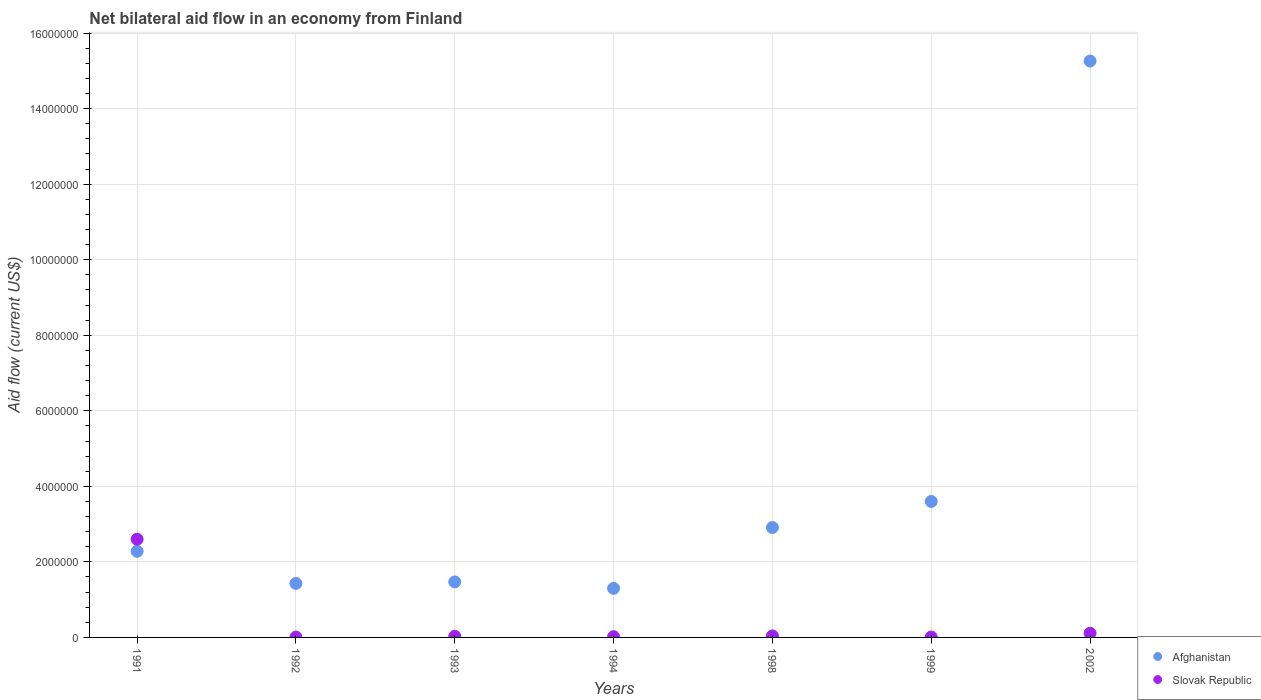What is the net bilateral aid flow in Slovak Republic in 1991?
Ensure brevity in your answer.  2.60e+06. Across all years, what is the maximum net bilateral aid flow in Afghanistan?
Your answer should be compact. 1.53e+07. Across all years, what is the minimum net bilateral aid flow in Afghanistan?
Your response must be concise. 1.30e+06. What is the total net bilateral aid flow in Slovak Republic in the graph?
Offer a terse response. 2.82e+06. What is the difference between the net bilateral aid flow in Slovak Republic in 1992 and that in 1994?
Your response must be concise. -10000. What is the difference between the net bilateral aid flow in Slovak Republic in 1993 and the net bilateral aid flow in Afghanistan in 2002?
Provide a short and direct response. -1.52e+07. What is the average net bilateral aid flow in Slovak Republic per year?
Ensure brevity in your answer.  4.03e+05. In the year 1999, what is the difference between the net bilateral aid flow in Afghanistan and net bilateral aid flow in Slovak Republic?
Keep it short and to the point. 3.59e+06. What is the ratio of the net bilateral aid flow in Slovak Republic in 1992 to that in 2002?
Your response must be concise. 0.09. Is the net bilateral aid flow in Afghanistan in 1998 less than that in 2002?
Keep it short and to the point. Yes. Is the difference between the net bilateral aid flow in Afghanistan in 1994 and 2002 greater than the difference between the net bilateral aid flow in Slovak Republic in 1994 and 2002?
Offer a terse response. No. What is the difference between the highest and the second highest net bilateral aid flow in Slovak Republic?
Provide a short and direct response. 2.49e+06. What is the difference between the highest and the lowest net bilateral aid flow in Afghanistan?
Ensure brevity in your answer.  1.40e+07. Is the sum of the net bilateral aid flow in Slovak Republic in 1994 and 1999 greater than the maximum net bilateral aid flow in Afghanistan across all years?
Your answer should be very brief. No. Does the net bilateral aid flow in Afghanistan monotonically increase over the years?
Make the answer very short. No. How many years are there in the graph?
Your answer should be compact. 7. Does the graph contain grids?
Your response must be concise. Yes. What is the title of the graph?
Provide a short and direct response. Net bilateral aid flow in an economy from Finland. What is the Aid flow (current US$) in Afghanistan in 1991?
Offer a very short reply. 2.28e+06. What is the Aid flow (current US$) of Slovak Republic in 1991?
Ensure brevity in your answer.  2.60e+06. What is the Aid flow (current US$) of Afghanistan in 1992?
Give a very brief answer. 1.43e+06. What is the Aid flow (current US$) of Afghanistan in 1993?
Ensure brevity in your answer.  1.47e+06. What is the Aid flow (current US$) in Slovak Republic in 1993?
Make the answer very short. 3.00e+04. What is the Aid flow (current US$) of Afghanistan in 1994?
Offer a terse response. 1.30e+06. What is the Aid flow (current US$) in Slovak Republic in 1994?
Make the answer very short. 2.00e+04. What is the Aid flow (current US$) of Afghanistan in 1998?
Ensure brevity in your answer.  2.91e+06. What is the Aid flow (current US$) of Afghanistan in 1999?
Make the answer very short. 3.60e+06. What is the Aid flow (current US$) of Afghanistan in 2002?
Offer a very short reply. 1.53e+07. Across all years, what is the maximum Aid flow (current US$) of Afghanistan?
Your answer should be very brief. 1.53e+07. Across all years, what is the maximum Aid flow (current US$) of Slovak Republic?
Keep it short and to the point. 2.60e+06. Across all years, what is the minimum Aid flow (current US$) in Afghanistan?
Offer a terse response. 1.30e+06. Across all years, what is the minimum Aid flow (current US$) in Slovak Republic?
Your answer should be very brief. 10000. What is the total Aid flow (current US$) of Afghanistan in the graph?
Offer a terse response. 2.82e+07. What is the total Aid flow (current US$) of Slovak Republic in the graph?
Ensure brevity in your answer.  2.82e+06. What is the difference between the Aid flow (current US$) in Afghanistan in 1991 and that in 1992?
Offer a terse response. 8.50e+05. What is the difference between the Aid flow (current US$) of Slovak Republic in 1991 and that in 1992?
Your response must be concise. 2.59e+06. What is the difference between the Aid flow (current US$) in Afghanistan in 1991 and that in 1993?
Keep it short and to the point. 8.10e+05. What is the difference between the Aid flow (current US$) in Slovak Republic in 1991 and that in 1993?
Provide a short and direct response. 2.57e+06. What is the difference between the Aid flow (current US$) of Afghanistan in 1991 and that in 1994?
Ensure brevity in your answer.  9.80e+05. What is the difference between the Aid flow (current US$) in Slovak Republic in 1991 and that in 1994?
Ensure brevity in your answer.  2.58e+06. What is the difference between the Aid flow (current US$) of Afghanistan in 1991 and that in 1998?
Your response must be concise. -6.30e+05. What is the difference between the Aid flow (current US$) of Slovak Republic in 1991 and that in 1998?
Offer a terse response. 2.56e+06. What is the difference between the Aid flow (current US$) of Afghanistan in 1991 and that in 1999?
Your answer should be very brief. -1.32e+06. What is the difference between the Aid flow (current US$) in Slovak Republic in 1991 and that in 1999?
Make the answer very short. 2.59e+06. What is the difference between the Aid flow (current US$) of Afghanistan in 1991 and that in 2002?
Your response must be concise. -1.30e+07. What is the difference between the Aid flow (current US$) in Slovak Republic in 1991 and that in 2002?
Keep it short and to the point. 2.49e+06. What is the difference between the Aid flow (current US$) in Afghanistan in 1992 and that in 1993?
Provide a succinct answer. -4.00e+04. What is the difference between the Aid flow (current US$) of Slovak Republic in 1992 and that in 1993?
Give a very brief answer. -2.00e+04. What is the difference between the Aid flow (current US$) of Afghanistan in 1992 and that in 1994?
Offer a terse response. 1.30e+05. What is the difference between the Aid flow (current US$) in Slovak Republic in 1992 and that in 1994?
Your answer should be very brief. -10000. What is the difference between the Aid flow (current US$) of Afghanistan in 1992 and that in 1998?
Keep it short and to the point. -1.48e+06. What is the difference between the Aid flow (current US$) of Slovak Republic in 1992 and that in 1998?
Your answer should be compact. -3.00e+04. What is the difference between the Aid flow (current US$) in Afghanistan in 1992 and that in 1999?
Keep it short and to the point. -2.17e+06. What is the difference between the Aid flow (current US$) of Afghanistan in 1992 and that in 2002?
Make the answer very short. -1.38e+07. What is the difference between the Aid flow (current US$) in Afghanistan in 1993 and that in 1994?
Offer a terse response. 1.70e+05. What is the difference between the Aid flow (current US$) in Afghanistan in 1993 and that in 1998?
Provide a short and direct response. -1.44e+06. What is the difference between the Aid flow (current US$) of Afghanistan in 1993 and that in 1999?
Make the answer very short. -2.13e+06. What is the difference between the Aid flow (current US$) in Afghanistan in 1993 and that in 2002?
Your response must be concise. -1.38e+07. What is the difference between the Aid flow (current US$) of Slovak Republic in 1993 and that in 2002?
Your answer should be very brief. -8.00e+04. What is the difference between the Aid flow (current US$) of Afghanistan in 1994 and that in 1998?
Ensure brevity in your answer.  -1.61e+06. What is the difference between the Aid flow (current US$) in Slovak Republic in 1994 and that in 1998?
Ensure brevity in your answer.  -2.00e+04. What is the difference between the Aid flow (current US$) of Afghanistan in 1994 and that in 1999?
Your answer should be compact. -2.30e+06. What is the difference between the Aid flow (current US$) of Slovak Republic in 1994 and that in 1999?
Provide a succinct answer. 10000. What is the difference between the Aid flow (current US$) of Afghanistan in 1994 and that in 2002?
Provide a short and direct response. -1.40e+07. What is the difference between the Aid flow (current US$) of Slovak Republic in 1994 and that in 2002?
Provide a succinct answer. -9.00e+04. What is the difference between the Aid flow (current US$) of Afghanistan in 1998 and that in 1999?
Ensure brevity in your answer.  -6.90e+05. What is the difference between the Aid flow (current US$) of Slovak Republic in 1998 and that in 1999?
Make the answer very short. 3.00e+04. What is the difference between the Aid flow (current US$) of Afghanistan in 1998 and that in 2002?
Your answer should be compact. -1.24e+07. What is the difference between the Aid flow (current US$) in Slovak Republic in 1998 and that in 2002?
Provide a short and direct response. -7.00e+04. What is the difference between the Aid flow (current US$) in Afghanistan in 1999 and that in 2002?
Your answer should be compact. -1.17e+07. What is the difference between the Aid flow (current US$) of Slovak Republic in 1999 and that in 2002?
Ensure brevity in your answer.  -1.00e+05. What is the difference between the Aid flow (current US$) in Afghanistan in 1991 and the Aid flow (current US$) in Slovak Republic in 1992?
Ensure brevity in your answer.  2.27e+06. What is the difference between the Aid flow (current US$) in Afghanistan in 1991 and the Aid flow (current US$) in Slovak Republic in 1993?
Give a very brief answer. 2.25e+06. What is the difference between the Aid flow (current US$) of Afghanistan in 1991 and the Aid flow (current US$) of Slovak Republic in 1994?
Your answer should be compact. 2.26e+06. What is the difference between the Aid flow (current US$) in Afghanistan in 1991 and the Aid flow (current US$) in Slovak Republic in 1998?
Keep it short and to the point. 2.24e+06. What is the difference between the Aid flow (current US$) of Afghanistan in 1991 and the Aid flow (current US$) of Slovak Republic in 1999?
Your answer should be very brief. 2.27e+06. What is the difference between the Aid flow (current US$) in Afghanistan in 1991 and the Aid flow (current US$) in Slovak Republic in 2002?
Offer a very short reply. 2.17e+06. What is the difference between the Aid flow (current US$) of Afghanistan in 1992 and the Aid flow (current US$) of Slovak Republic in 1993?
Offer a very short reply. 1.40e+06. What is the difference between the Aid flow (current US$) in Afghanistan in 1992 and the Aid flow (current US$) in Slovak Republic in 1994?
Your response must be concise. 1.41e+06. What is the difference between the Aid flow (current US$) of Afghanistan in 1992 and the Aid flow (current US$) of Slovak Republic in 1998?
Give a very brief answer. 1.39e+06. What is the difference between the Aid flow (current US$) of Afghanistan in 1992 and the Aid flow (current US$) of Slovak Republic in 1999?
Keep it short and to the point. 1.42e+06. What is the difference between the Aid flow (current US$) of Afghanistan in 1992 and the Aid flow (current US$) of Slovak Republic in 2002?
Keep it short and to the point. 1.32e+06. What is the difference between the Aid flow (current US$) in Afghanistan in 1993 and the Aid flow (current US$) in Slovak Republic in 1994?
Keep it short and to the point. 1.45e+06. What is the difference between the Aid flow (current US$) in Afghanistan in 1993 and the Aid flow (current US$) in Slovak Republic in 1998?
Your answer should be very brief. 1.43e+06. What is the difference between the Aid flow (current US$) in Afghanistan in 1993 and the Aid flow (current US$) in Slovak Republic in 1999?
Ensure brevity in your answer.  1.46e+06. What is the difference between the Aid flow (current US$) in Afghanistan in 1993 and the Aid flow (current US$) in Slovak Republic in 2002?
Ensure brevity in your answer.  1.36e+06. What is the difference between the Aid flow (current US$) of Afghanistan in 1994 and the Aid flow (current US$) of Slovak Republic in 1998?
Offer a very short reply. 1.26e+06. What is the difference between the Aid flow (current US$) in Afghanistan in 1994 and the Aid flow (current US$) in Slovak Republic in 1999?
Your answer should be very brief. 1.29e+06. What is the difference between the Aid flow (current US$) of Afghanistan in 1994 and the Aid flow (current US$) of Slovak Republic in 2002?
Provide a short and direct response. 1.19e+06. What is the difference between the Aid flow (current US$) in Afghanistan in 1998 and the Aid flow (current US$) in Slovak Republic in 1999?
Make the answer very short. 2.90e+06. What is the difference between the Aid flow (current US$) of Afghanistan in 1998 and the Aid flow (current US$) of Slovak Republic in 2002?
Your answer should be very brief. 2.80e+06. What is the difference between the Aid flow (current US$) in Afghanistan in 1999 and the Aid flow (current US$) in Slovak Republic in 2002?
Provide a succinct answer. 3.49e+06. What is the average Aid flow (current US$) in Afghanistan per year?
Offer a very short reply. 4.04e+06. What is the average Aid flow (current US$) of Slovak Republic per year?
Provide a short and direct response. 4.03e+05. In the year 1991, what is the difference between the Aid flow (current US$) in Afghanistan and Aid flow (current US$) in Slovak Republic?
Ensure brevity in your answer.  -3.20e+05. In the year 1992, what is the difference between the Aid flow (current US$) in Afghanistan and Aid flow (current US$) in Slovak Republic?
Keep it short and to the point. 1.42e+06. In the year 1993, what is the difference between the Aid flow (current US$) in Afghanistan and Aid flow (current US$) in Slovak Republic?
Provide a succinct answer. 1.44e+06. In the year 1994, what is the difference between the Aid flow (current US$) in Afghanistan and Aid flow (current US$) in Slovak Republic?
Provide a short and direct response. 1.28e+06. In the year 1998, what is the difference between the Aid flow (current US$) in Afghanistan and Aid flow (current US$) in Slovak Republic?
Make the answer very short. 2.87e+06. In the year 1999, what is the difference between the Aid flow (current US$) in Afghanistan and Aid flow (current US$) in Slovak Republic?
Give a very brief answer. 3.59e+06. In the year 2002, what is the difference between the Aid flow (current US$) of Afghanistan and Aid flow (current US$) of Slovak Republic?
Your response must be concise. 1.52e+07. What is the ratio of the Aid flow (current US$) of Afghanistan in 1991 to that in 1992?
Offer a very short reply. 1.59. What is the ratio of the Aid flow (current US$) in Slovak Republic in 1991 to that in 1992?
Make the answer very short. 260. What is the ratio of the Aid flow (current US$) in Afghanistan in 1991 to that in 1993?
Offer a very short reply. 1.55. What is the ratio of the Aid flow (current US$) in Slovak Republic in 1991 to that in 1993?
Make the answer very short. 86.67. What is the ratio of the Aid flow (current US$) in Afghanistan in 1991 to that in 1994?
Give a very brief answer. 1.75. What is the ratio of the Aid flow (current US$) in Slovak Republic in 1991 to that in 1994?
Provide a succinct answer. 130. What is the ratio of the Aid flow (current US$) of Afghanistan in 1991 to that in 1998?
Ensure brevity in your answer.  0.78. What is the ratio of the Aid flow (current US$) in Slovak Republic in 1991 to that in 1998?
Offer a terse response. 65. What is the ratio of the Aid flow (current US$) in Afghanistan in 1991 to that in 1999?
Ensure brevity in your answer.  0.63. What is the ratio of the Aid flow (current US$) in Slovak Republic in 1991 to that in 1999?
Keep it short and to the point. 260. What is the ratio of the Aid flow (current US$) in Afghanistan in 1991 to that in 2002?
Make the answer very short. 0.15. What is the ratio of the Aid flow (current US$) of Slovak Republic in 1991 to that in 2002?
Offer a terse response. 23.64. What is the ratio of the Aid flow (current US$) of Afghanistan in 1992 to that in 1993?
Your answer should be compact. 0.97. What is the ratio of the Aid flow (current US$) of Slovak Republic in 1992 to that in 1993?
Your answer should be compact. 0.33. What is the ratio of the Aid flow (current US$) in Slovak Republic in 1992 to that in 1994?
Make the answer very short. 0.5. What is the ratio of the Aid flow (current US$) of Afghanistan in 1992 to that in 1998?
Offer a very short reply. 0.49. What is the ratio of the Aid flow (current US$) of Slovak Republic in 1992 to that in 1998?
Give a very brief answer. 0.25. What is the ratio of the Aid flow (current US$) in Afghanistan in 1992 to that in 1999?
Give a very brief answer. 0.4. What is the ratio of the Aid flow (current US$) of Slovak Republic in 1992 to that in 1999?
Offer a terse response. 1. What is the ratio of the Aid flow (current US$) of Afghanistan in 1992 to that in 2002?
Provide a short and direct response. 0.09. What is the ratio of the Aid flow (current US$) of Slovak Republic in 1992 to that in 2002?
Your response must be concise. 0.09. What is the ratio of the Aid flow (current US$) of Afghanistan in 1993 to that in 1994?
Ensure brevity in your answer.  1.13. What is the ratio of the Aid flow (current US$) of Slovak Republic in 1993 to that in 1994?
Offer a very short reply. 1.5. What is the ratio of the Aid flow (current US$) in Afghanistan in 1993 to that in 1998?
Keep it short and to the point. 0.51. What is the ratio of the Aid flow (current US$) of Slovak Republic in 1993 to that in 1998?
Your answer should be very brief. 0.75. What is the ratio of the Aid flow (current US$) of Afghanistan in 1993 to that in 1999?
Ensure brevity in your answer.  0.41. What is the ratio of the Aid flow (current US$) of Afghanistan in 1993 to that in 2002?
Your answer should be compact. 0.1. What is the ratio of the Aid flow (current US$) of Slovak Republic in 1993 to that in 2002?
Keep it short and to the point. 0.27. What is the ratio of the Aid flow (current US$) of Afghanistan in 1994 to that in 1998?
Keep it short and to the point. 0.45. What is the ratio of the Aid flow (current US$) of Slovak Republic in 1994 to that in 1998?
Ensure brevity in your answer.  0.5. What is the ratio of the Aid flow (current US$) of Afghanistan in 1994 to that in 1999?
Ensure brevity in your answer.  0.36. What is the ratio of the Aid flow (current US$) in Slovak Republic in 1994 to that in 1999?
Offer a very short reply. 2. What is the ratio of the Aid flow (current US$) in Afghanistan in 1994 to that in 2002?
Give a very brief answer. 0.09. What is the ratio of the Aid flow (current US$) of Slovak Republic in 1994 to that in 2002?
Offer a very short reply. 0.18. What is the ratio of the Aid flow (current US$) in Afghanistan in 1998 to that in 1999?
Offer a very short reply. 0.81. What is the ratio of the Aid flow (current US$) of Afghanistan in 1998 to that in 2002?
Your answer should be compact. 0.19. What is the ratio of the Aid flow (current US$) in Slovak Republic in 1998 to that in 2002?
Provide a short and direct response. 0.36. What is the ratio of the Aid flow (current US$) in Afghanistan in 1999 to that in 2002?
Give a very brief answer. 0.24. What is the ratio of the Aid flow (current US$) in Slovak Republic in 1999 to that in 2002?
Provide a succinct answer. 0.09. What is the difference between the highest and the second highest Aid flow (current US$) of Afghanistan?
Your answer should be very brief. 1.17e+07. What is the difference between the highest and the second highest Aid flow (current US$) in Slovak Republic?
Offer a terse response. 2.49e+06. What is the difference between the highest and the lowest Aid flow (current US$) of Afghanistan?
Offer a very short reply. 1.40e+07. What is the difference between the highest and the lowest Aid flow (current US$) in Slovak Republic?
Ensure brevity in your answer.  2.59e+06. 